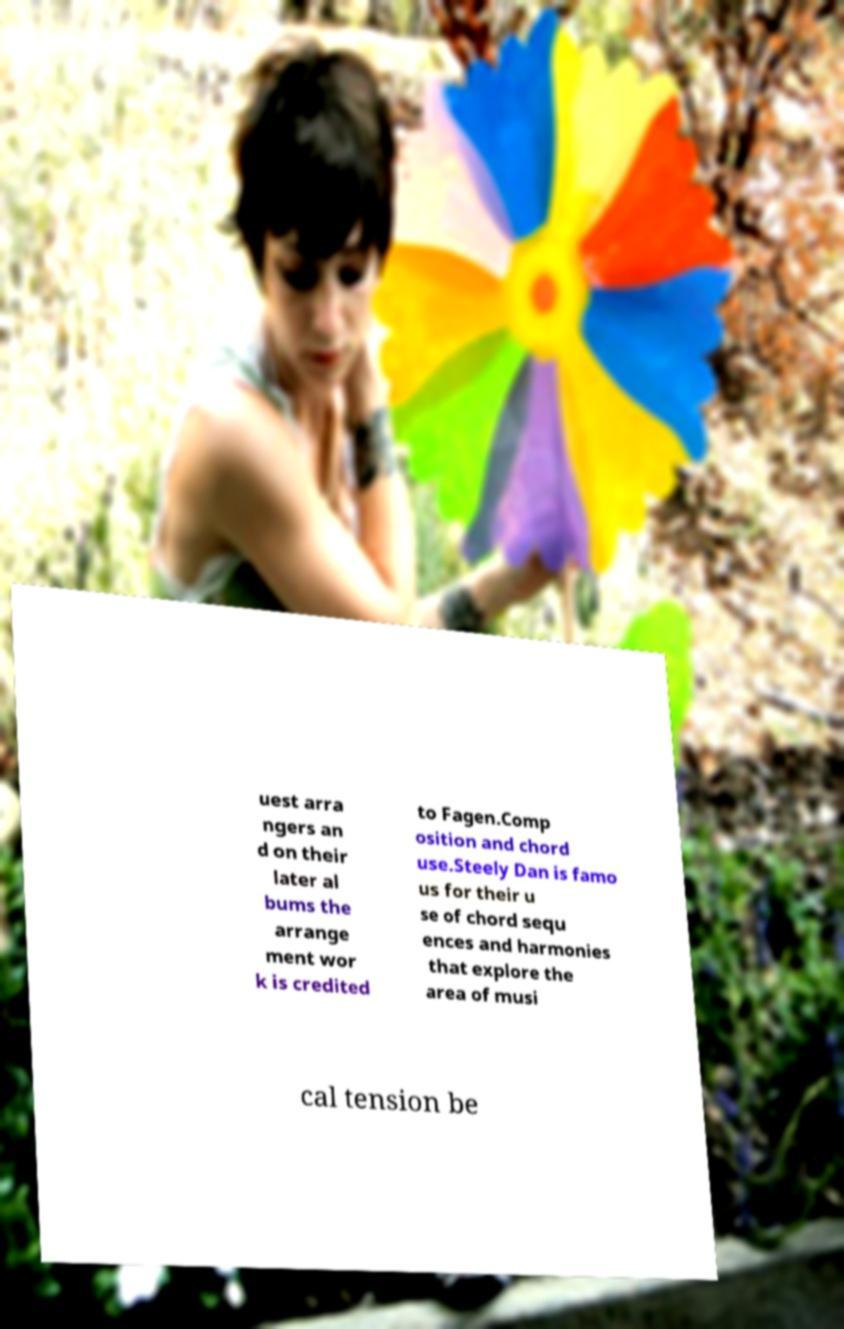What messages or text are displayed in this image? I need them in a readable, typed format. uest arra ngers an d on their later al bums the arrange ment wor k is credited to Fagen.Comp osition and chord use.Steely Dan is famo us for their u se of chord sequ ences and harmonies that explore the area of musi cal tension be 